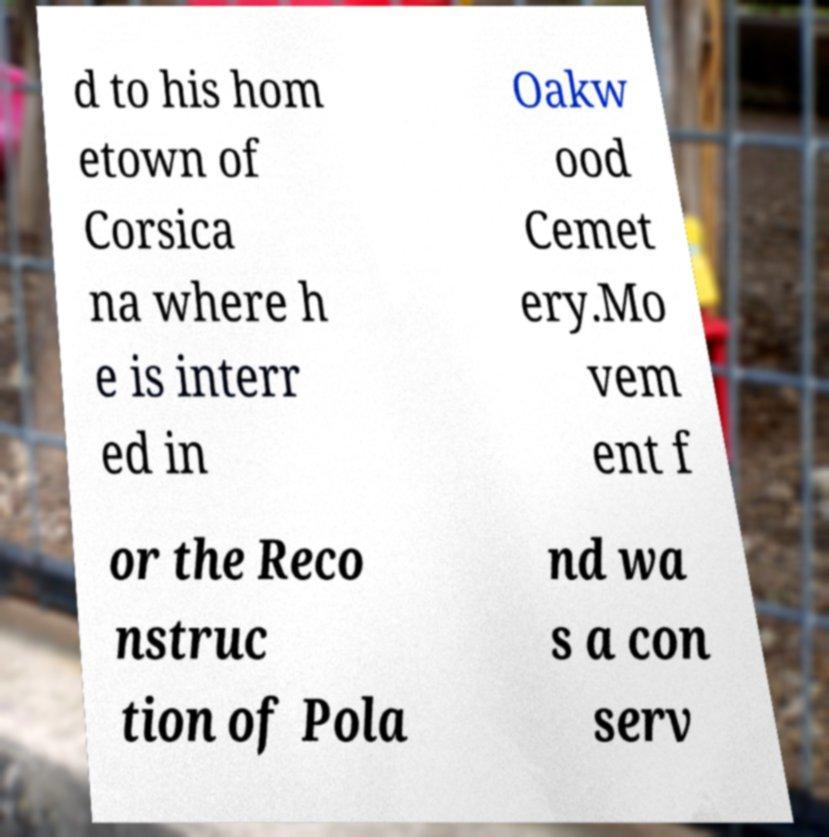Please identify and transcribe the text found in this image. d to his hom etown of Corsica na where h e is interr ed in Oakw ood Cemet ery.Mo vem ent f or the Reco nstruc tion of Pola nd wa s a con serv 